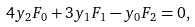Convert formula to latex. <formula><loc_0><loc_0><loc_500><loc_500>4 y _ { 2 } F _ { 0 } + 3 y _ { 1 } F _ { 1 } - y _ { 0 } F _ { 2 } = 0 ,</formula> 